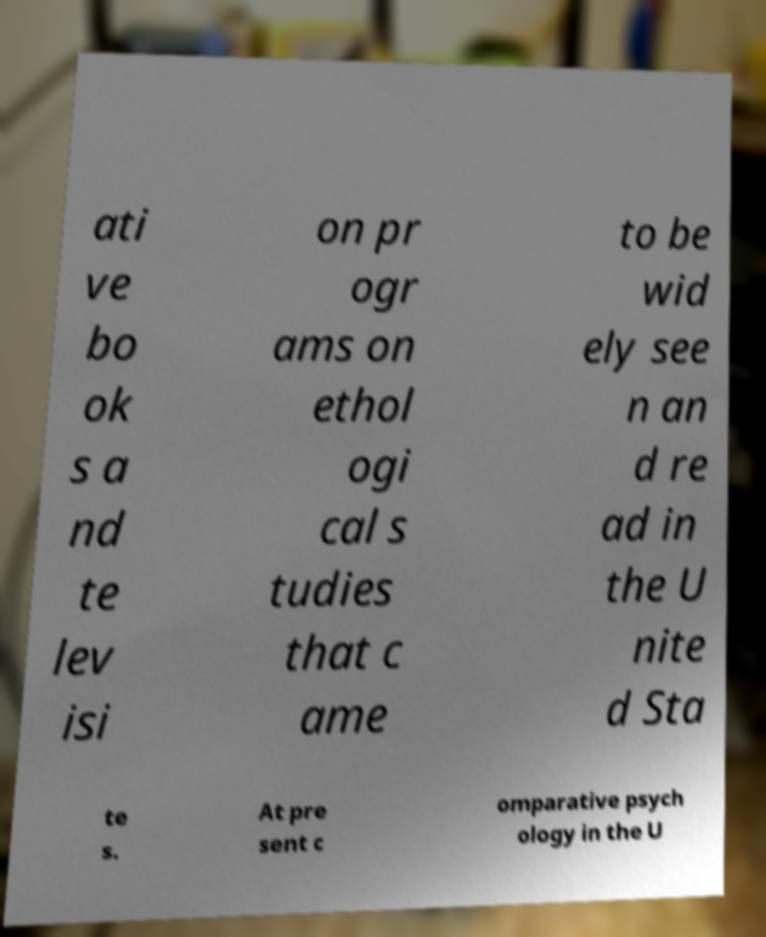Could you assist in decoding the text presented in this image and type it out clearly? ati ve bo ok s a nd te lev isi on pr ogr ams on ethol ogi cal s tudies that c ame to be wid ely see n an d re ad in the U nite d Sta te s. At pre sent c omparative psych ology in the U 